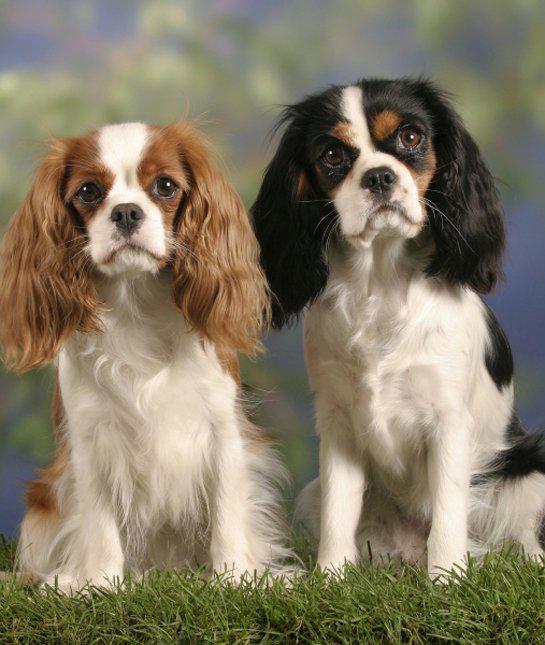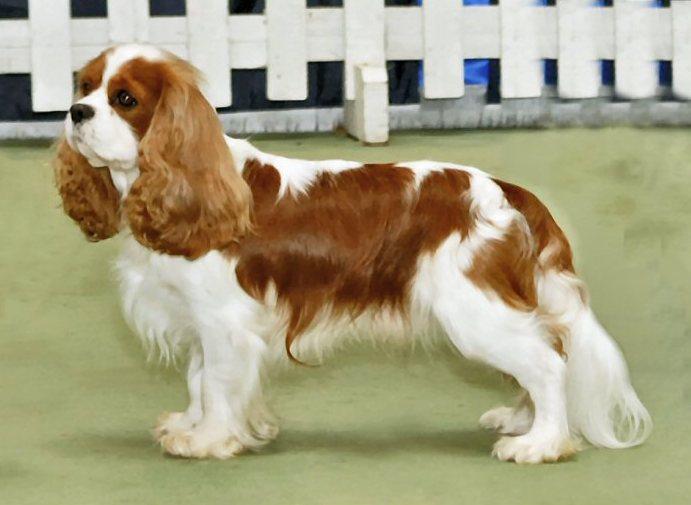The first image is the image on the left, the second image is the image on the right. Analyze the images presented: Is the assertion "The dog on the right is standing in the grass." valid? Answer yes or no. No. The first image is the image on the left, the second image is the image on the right. Assess this claim about the two images: "Two dogs on grassy ground are visible in the left image.". Correct or not? Answer yes or no. Yes. 